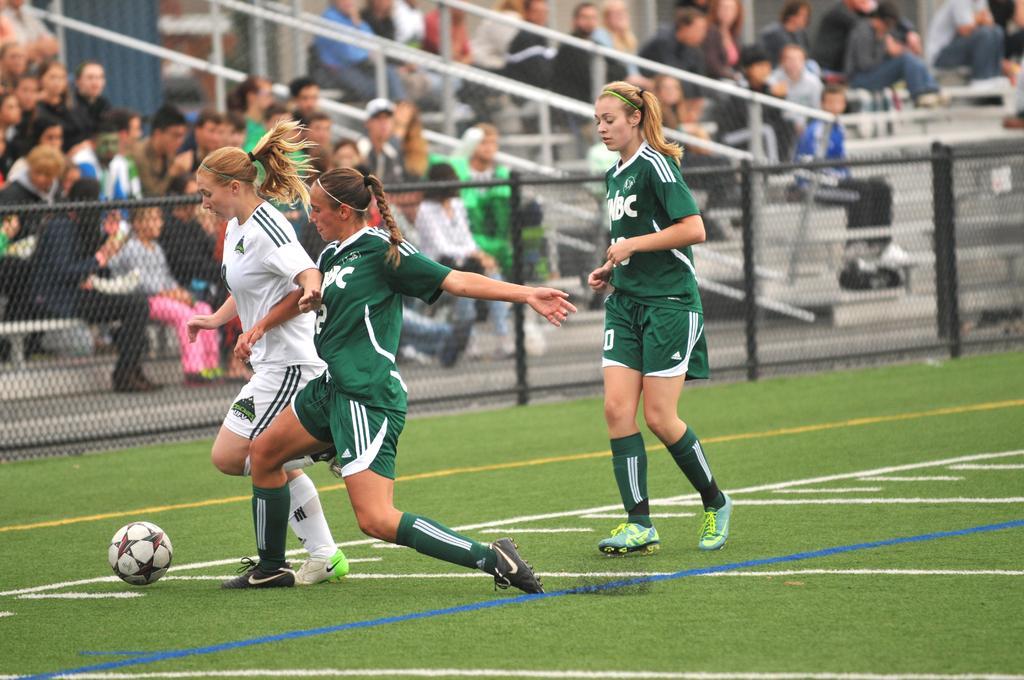Describe this image in one or two sentences. In this image we can see a few people, among them some are sitting and some are playing in the ground, we can see the fence and poles. 